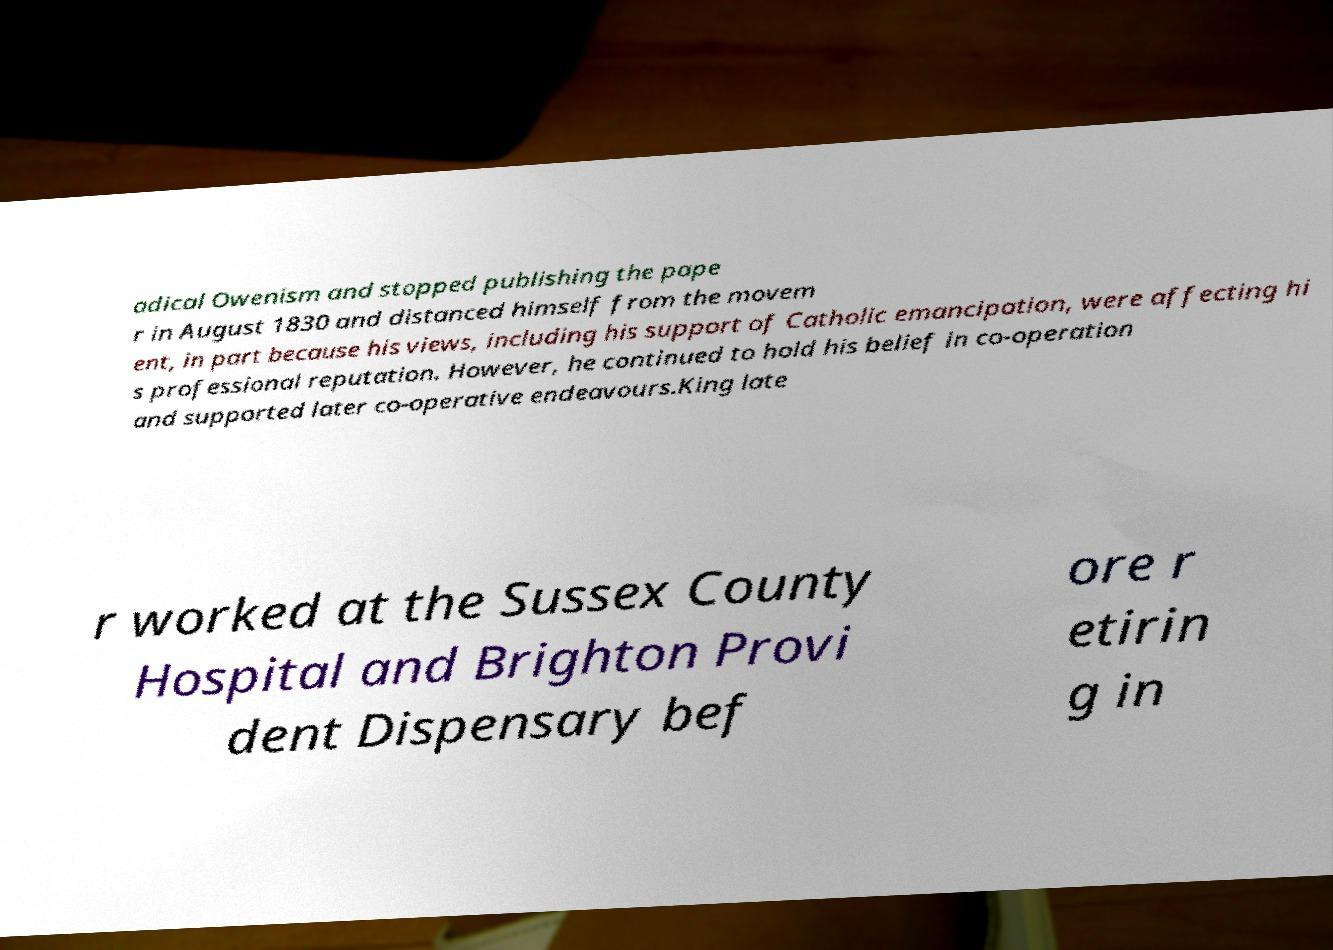Please read and relay the text visible in this image. What does it say? adical Owenism and stopped publishing the pape r in August 1830 and distanced himself from the movem ent, in part because his views, including his support of Catholic emancipation, were affecting hi s professional reputation. However, he continued to hold his belief in co-operation and supported later co-operative endeavours.King late r worked at the Sussex County Hospital and Brighton Provi dent Dispensary bef ore r etirin g in 